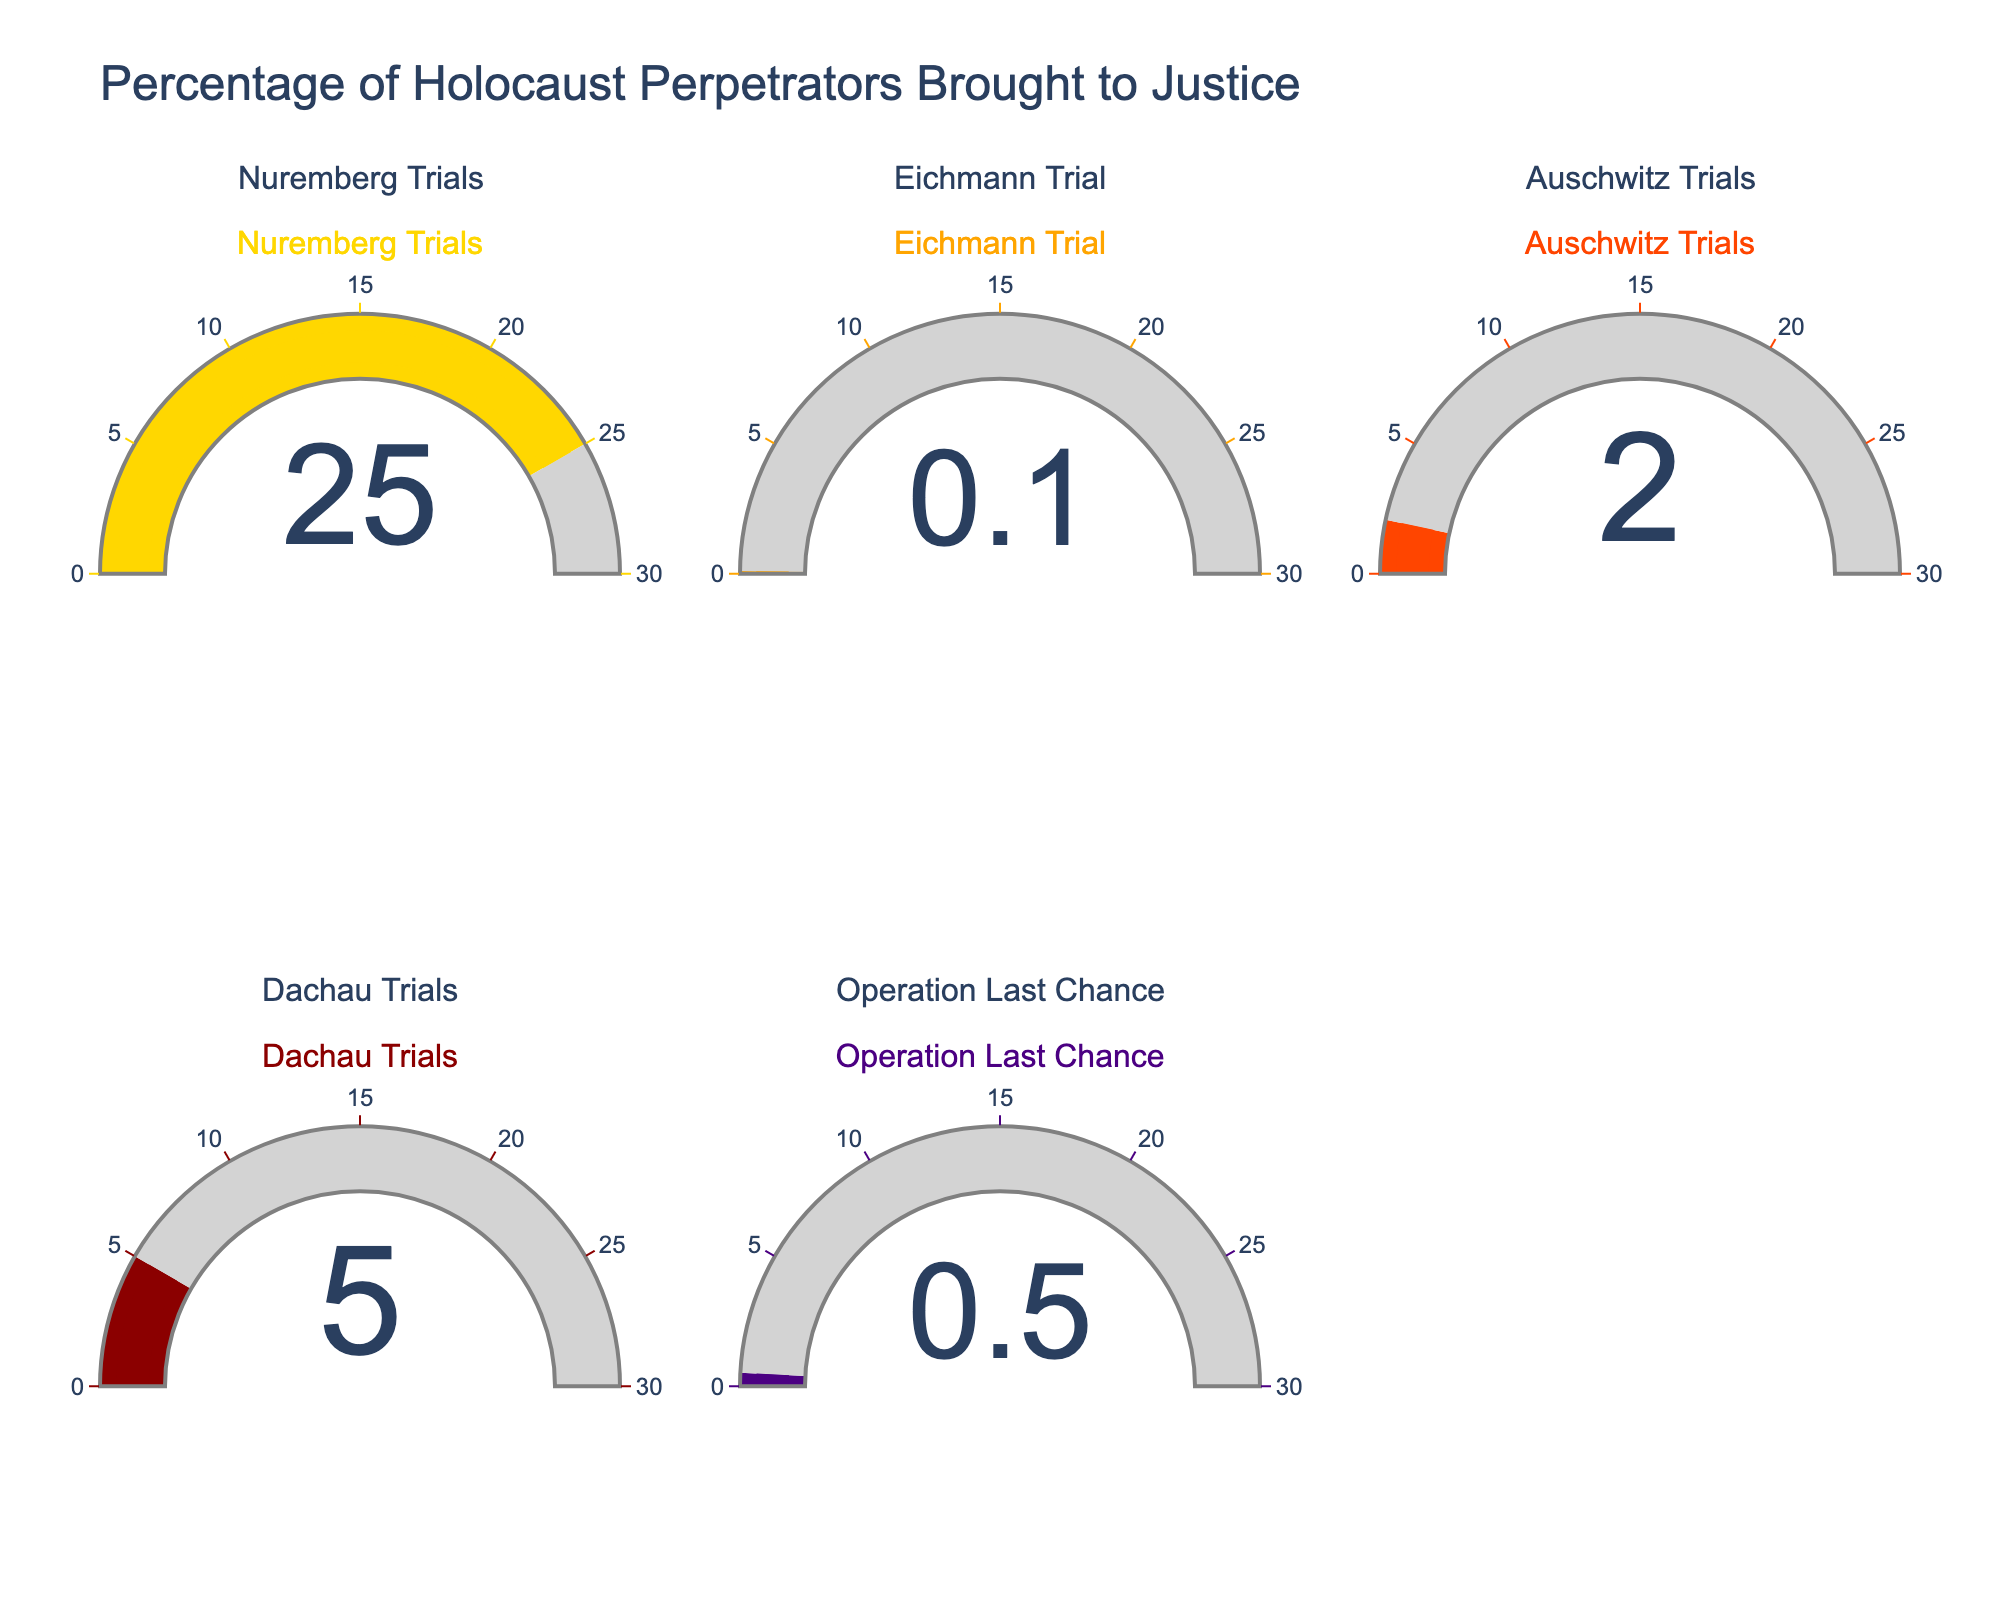What's the title of the figure? The title is displayed at the top of the figure. It reads "Percentage of Holocaust Perpetrators Brought to Justice".
Answer: Percentage of Holocaust Perpetrators Brought to Justice Which trial has the highest percentage of perpetrators brought to justice? By observing the gauges, the Nuremberg Trials show the highest percentage at 25%.
Answer: Nuremberg Trials Which categories have a percentage lower than 1%? The gauges for the Eichmann Trial and Operation Last Chance both show percentages lower than 1%, specifically 0.1% and 0.5% respectively.
Answer: Eichmann Trial and Operation Last Chance What's the combined percentage of perpetrators brought to justice by the Auschwitz and Dachau Trials? The percentages for the Auschwitz Trials and Dachau Trials are 2% and 5%, respectively. Adding these gives 2% + 5% = 7%.
Answer: 7% Which color is used for the Nuremberg Trials gauge? By checking the color associated with the Nuremberg Trials gauge, it is golden.
Answer: Golden How much higher is the percentage for the Nuremberg Trials compared to the Auschwitz Trials? The Nuremberg Trials have 25% while the Auschwitz Trials have 2%. The difference is 25% - 2% = 23%.
Answer: 23% What is the average percentage of all the trials combined? The percentages are 25%, 0.1%, 2%, 5%, and 0.5%. Adding them gives 25 + 0.1 + 2 + 5 + 0.5 = 32.6. Dividing by 5 gives 32.6 / 5 = 6.52.
Answer: 6.52 What is the position of the Dachau Trials gauge in the figure? The Dachau Trials gauge is found in the bottom row, second column.
Answer: Bottom row, second column 